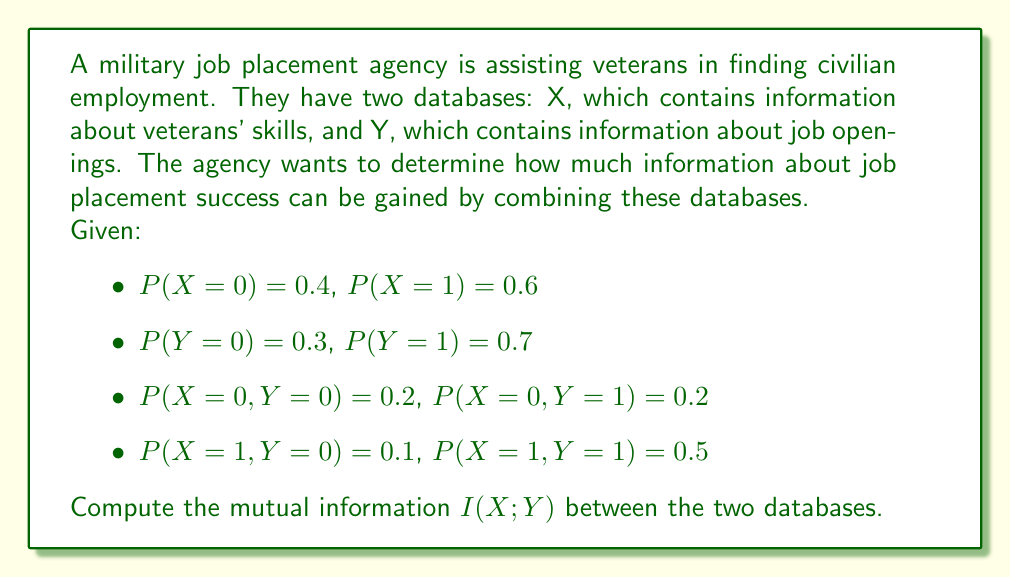Can you answer this question? To compute the mutual information I(X;Y), we'll follow these steps:

1. Calculate the marginal probabilities P(X) and P(Y) (given in the problem).

2. Calculate the joint probability distribution P(X,Y) (given in the problem).

3. Calculate the mutual information using the formula:

   $$I(X;Y) = \sum_{x \in X} \sum_{y \in Y} P(x,y) \log_2 \left(\frac{P(x,y)}{P(x)P(y)}\right)$$

Step 1: Marginal probabilities (given)
P(X = 0) = 0.4, P(X = 1) = 0.6
P(Y = 0) = 0.3, P(Y = 1) = 0.7

Step 2: Joint probability distribution (given)
P(X = 0, Y = 0) = 0.2, P(X = 0, Y = 1) = 0.2
P(X = 1, Y = 0) = 0.1, P(X = 1, Y = 1) = 0.5

Step 3: Calculate mutual information
We'll calculate each term of the sum separately:

For X = 0, Y = 0:
$$0.2 \log_2 \left(\frac{0.2}{0.4 \cdot 0.3}\right) = 0.2 \log_2 (1.6667) = 0.2 \cdot 0.7370 = 0.1474$$

For X = 0, Y = 1:
$$0.2 \log_2 \left(\frac{0.2}{0.4 \cdot 0.7}\right) = 0.2 \log_2 (0.7143) = 0.2 \cdot (-0.4854) = -0.0971$$

For X = 1, Y = 0:
$$0.1 \log_2 \left(\frac{0.1}{0.6 \cdot 0.3}\right) = 0.1 \log_2 (0.5556) = 0.1 \cdot (-0.8480) = -0.0848$$

For X = 1, Y = 1:
$$0.5 \log_2 \left(\frac{0.5}{0.6 \cdot 0.7}\right) = 0.5 \log_2 (1.1905) = 0.5 \cdot 0.2516 = 0.1258$$

Sum all terms:
$$I(X;Y) = 0.1474 - 0.0971 - 0.0848 + 0.1258 = 0.0913$$
Answer: The mutual information I(X;Y) between the two databases is approximately 0.0913 bits. 